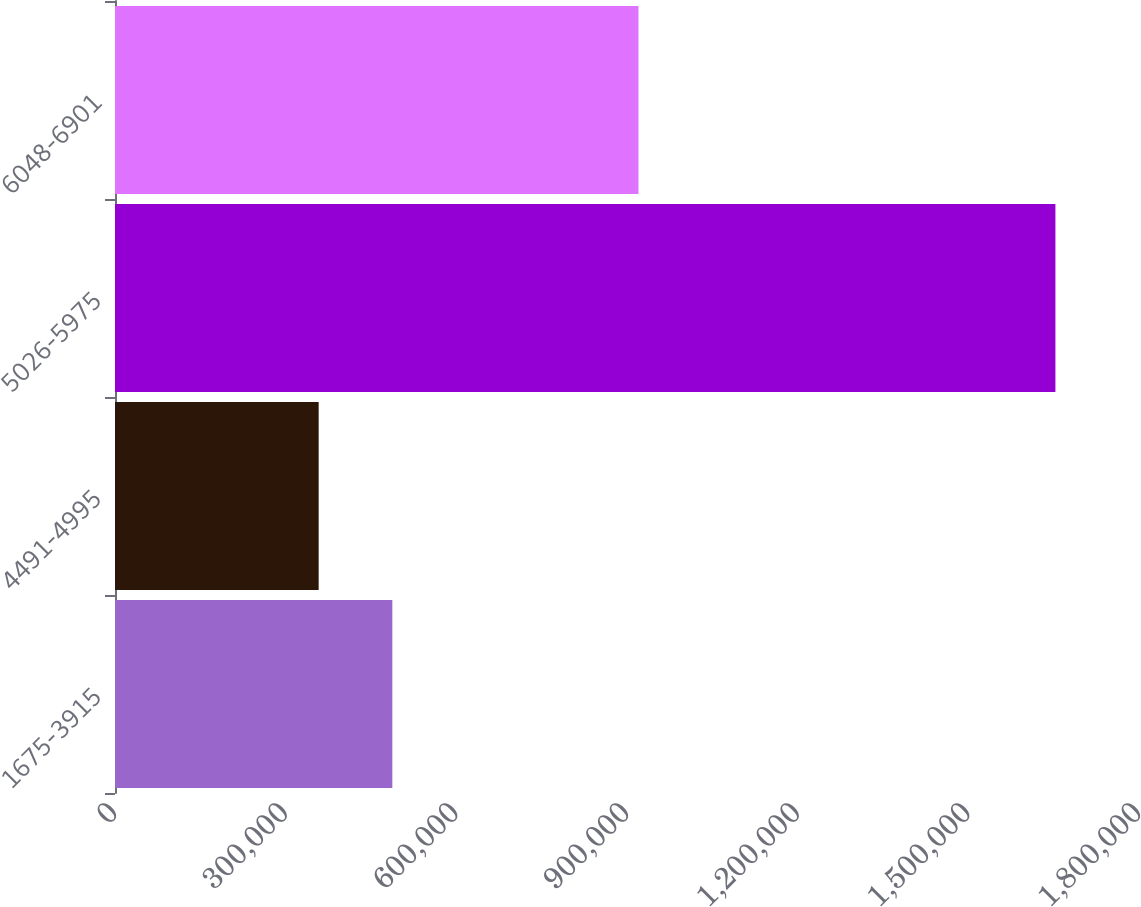<chart> <loc_0><loc_0><loc_500><loc_500><bar_chart><fcel>1675-3915<fcel>4491-4995<fcel>5026-5975<fcel>6048-6901<nl><fcel>487515<fcel>358007<fcel>1.65308e+06<fcel>920193<nl></chart> 